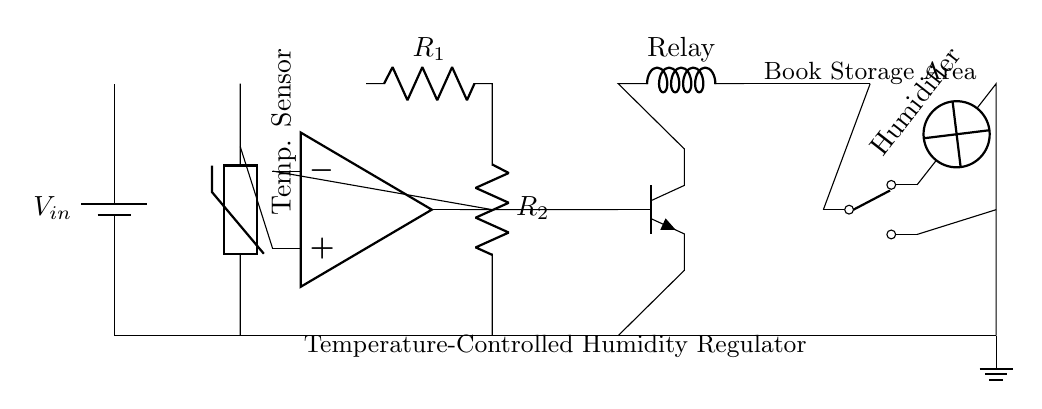What is the function of the temperature sensor? The temperature sensor measures the ambient temperature, which is critical for regulating humidity as it influences moisture absorption properties of air.
Answer: measures temperature What components are used to form the comparator? The comparator is formed by an operational amplifier and two resistors, R1 and R2, which set the reference voltage used for comparing the sensor's output.
Answer: operational amplifier and resistors How does the transistor contribute to the circuit? The transistor acts as a switch that controls the relay based on the output of the comparator; it allows or cuts off the current to the relay, which in turn activates the humidifier.
Answer: as a switch What is the purpose of the relay in this circuit? The relay is used to control higher power devices, like the humidifier, by isolating them from the control circuitry and allowing them to be switched on or off safely.
Answer: control humidifier What is the role of the humidifier in the circuit? The humidifier adds moisture to the air in the book storage area to maintain optimal humidity, which is crucial for preserving antique books.
Answer: maintains humidity What happens when the temperature rises above the set point? When the temperature rises, the comparator's output will change, which will turn on the transistor, activating the relay, and consequently the humidifier to increase humidity.
Answer: activates humidifier How many voltage connections are there in this circuit? There are two voltage connections: one from the battery for power supply and one from the output of the operational amplifier to the base of the transistor.
Answer: two 